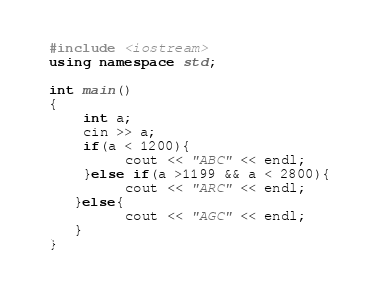Convert code to text. <code><loc_0><loc_0><loc_500><loc_500><_C++_>#include <iostream>
using namespace std;

int main()
{
    int a;
    cin >> a;
    if(a < 1200){
         cout << "ABC" << endl;
    }else if(a >1199 && a < 2800){
         cout << "ARC" << endl;
   }else{
         cout << "AGC" << endl;
   }
}</code> 